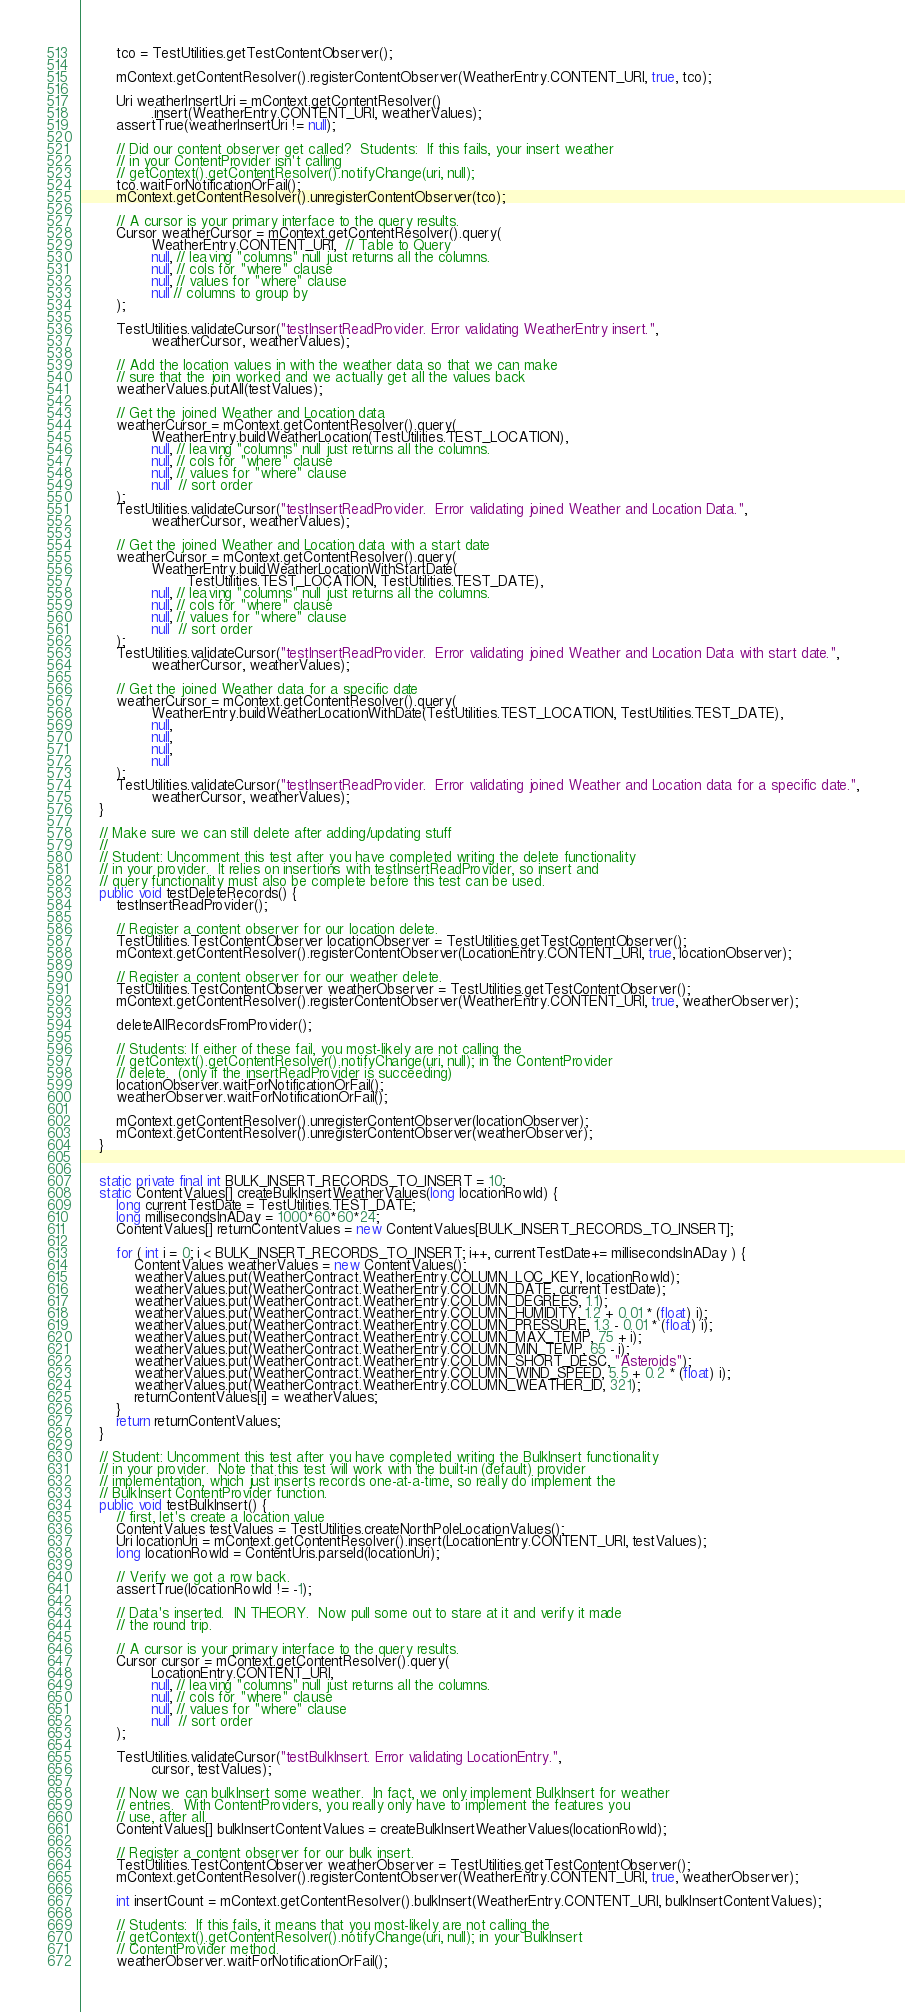Convert code to text. <code><loc_0><loc_0><loc_500><loc_500><_Java_>        tco = TestUtilities.getTestContentObserver();

        mContext.getContentResolver().registerContentObserver(WeatherEntry.CONTENT_URI, true, tco);

        Uri weatherInsertUri = mContext.getContentResolver()
                .insert(WeatherEntry.CONTENT_URI, weatherValues);
        assertTrue(weatherInsertUri != null);

        // Did our content observer get called?  Students:  If this fails, your insert weather
        // in your ContentProvider isn't calling
        // getContext().getContentResolver().notifyChange(uri, null);
        tco.waitForNotificationOrFail();
        mContext.getContentResolver().unregisterContentObserver(tco);

        // A cursor is your primary interface to the query results.
        Cursor weatherCursor = mContext.getContentResolver().query(
                WeatherEntry.CONTENT_URI,  // Table to Query
                null, // leaving "columns" null just returns all the columns.
                null, // cols for "where" clause
                null, // values for "where" clause
                null // columns to group by
        );

        TestUtilities.validateCursor("testInsertReadProvider. Error validating WeatherEntry insert.",
                weatherCursor, weatherValues);

        // Add the location values in with the weather data so that we can make
        // sure that the join worked and we actually get all the values back
        weatherValues.putAll(testValues);

        // Get the joined Weather and Location data
        weatherCursor = mContext.getContentResolver().query(
                WeatherEntry.buildWeatherLocation(TestUtilities.TEST_LOCATION),
                null, // leaving "columns" null just returns all the columns.
                null, // cols for "where" clause
                null, // values for "where" clause
                null  // sort order
        );
        TestUtilities.validateCursor("testInsertReadProvider.  Error validating joined Weather and Location Data.",
                weatherCursor, weatherValues);

        // Get the joined Weather and Location data with a start date
        weatherCursor = mContext.getContentResolver().query(
                WeatherEntry.buildWeatherLocationWithStartDate(
                        TestUtilities.TEST_LOCATION, TestUtilities.TEST_DATE),
                null, // leaving "columns" null just returns all the columns.
                null, // cols for "where" clause
                null, // values for "where" clause
                null  // sort order
        );
        TestUtilities.validateCursor("testInsertReadProvider.  Error validating joined Weather and Location Data with start date.",
                weatherCursor, weatherValues);

        // Get the joined Weather data for a specific date
        weatherCursor = mContext.getContentResolver().query(
                WeatherEntry.buildWeatherLocationWithDate(TestUtilities.TEST_LOCATION, TestUtilities.TEST_DATE),
                null,
                null,
                null,
                null
        );
        TestUtilities.validateCursor("testInsertReadProvider.  Error validating joined Weather and Location data for a specific date.",
                weatherCursor, weatherValues);
    }

    // Make sure we can still delete after adding/updating stuff
    //
    // Student: Uncomment this test after you have completed writing the delete functionality
    // in your provider.  It relies on insertions with testInsertReadProvider, so insert and
    // query functionality must also be complete before this test can be used.
    public void testDeleteRecords() {
        testInsertReadProvider();

        // Register a content observer for our location delete.
        TestUtilities.TestContentObserver locationObserver = TestUtilities.getTestContentObserver();
        mContext.getContentResolver().registerContentObserver(LocationEntry.CONTENT_URI, true, locationObserver);

        // Register a content observer for our weather delete.
        TestUtilities.TestContentObserver weatherObserver = TestUtilities.getTestContentObserver();
        mContext.getContentResolver().registerContentObserver(WeatherEntry.CONTENT_URI, true, weatherObserver);

        deleteAllRecordsFromProvider();

        // Students: If either of these fail, you most-likely are not calling the
        // getContext().getContentResolver().notifyChange(uri, null); in the ContentProvider
        // delete.  (only if the insertReadProvider is succeeding)
        locationObserver.waitForNotificationOrFail();
        weatherObserver.waitForNotificationOrFail();

        mContext.getContentResolver().unregisterContentObserver(locationObserver);
        mContext.getContentResolver().unregisterContentObserver(weatherObserver);
    }


    static private final int BULK_INSERT_RECORDS_TO_INSERT = 10;
    static ContentValues[] createBulkInsertWeatherValues(long locationRowId) {
        long currentTestDate = TestUtilities.TEST_DATE;
        long millisecondsInADay = 1000*60*60*24;
        ContentValues[] returnContentValues = new ContentValues[BULK_INSERT_RECORDS_TO_INSERT];

        for ( int i = 0; i < BULK_INSERT_RECORDS_TO_INSERT; i++, currentTestDate+= millisecondsInADay ) {
            ContentValues weatherValues = new ContentValues();
            weatherValues.put(WeatherContract.WeatherEntry.COLUMN_LOC_KEY, locationRowId);
            weatherValues.put(WeatherContract.WeatherEntry.COLUMN_DATE, currentTestDate);
            weatherValues.put(WeatherContract.WeatherEntry.COLUMN_DEGREES, 1.1);
            weatherValues.put(WeatherContract.WeatherEntry.COLUMN_HUMIDITY, 1.2 + 0.01 * (float) i);
            weatherValues.put(WeatherContract.WeatherEntry.COLUMN_PRESSURE, 1.3 - 0.01 * (float) i);
            weatherValues.put(WeatherContract.WeatherEntry.COLUMN_MAX_TEMP, 75 + i);
            weatherValues.put(WeatherContract.WeatherEntry.COLUMN_MIN_TEMP, 65 - i);
            weatherValues.put(WeatherContract.WeatherEntry.COLUMN_SHORT_DESC, "Asteroids");
            weatherValues.put(WeatherContract.WeatherEntry.COLUMN_WIND_SPEED, 5.5 + 0.2 * (float) i);
            weatherValues.put(WeatherContract.WeatherEntry.COLUMN_WEATHER_ID, 321);
            returnContentValues[i] = weatherValues;
        }
        return returnContentValues;
    }

    // Student: Uncomment this test after you have completed writing the BulkInsert functionality
    // in your provider.  Note that this test will work with the built-in (default) provider
    // implementation, which just inserts records one-at-a-time, so really do implement the
    // BulkInsert ContentProvider function.
    public void testBulkInsert() {
        // first, let's create a location value
        ContentValues testValues = TestUtilities.createNorthPoleLocationValues();
        Uri locationUri = mContext.getContentResolver().insert(LocationEntry.CONTENT_URI, testValues);
        long locationRowId = ContentUris.parseId(locationUri);

        // Verify we got a row back.
        assertTrue(locationRowId != -1);

        // Data's inserted.  IN THEORY.  Now pull some out to stare at it and verify it made
        // the round trip.

        // A cursor is your primary interface to the query results.
        Cursor cursor = mContext.getContentResolver().query(
                LocationEntry.CONTENT_URI,
                null, // leaving "columns" null just returns all the columns.
                null, // cols for "where" clause
                null, // values for "where" clause
                null  // sort order
        );

        TestUtilities.validateCursor("testBulkInsert. Error validating LocationEntry.",
                cursor, testValues);

        // Now we can bulkInsert some weather.  In fact, we only implement BulkInsert for weather
        // entries.  With ContentProviders, you really only have to implement the features you
        // use, after all.
        ContentValues[] bulkInsertContentValues = createBulkInsertWeatherValues(locationRowId);

        // Register a content observer for our bulk insert.
        TestUtilities.TestContentObserver weatherObserver = TestUtilities.getTestContentObserver();
        mContext.getContentResolver().registerContentObserver(WeatherEntry.CONTENT_URI, true, weatherObserver);

        int insertCount = mContext.getContentResolver().bulkInsert(WeatherEntry.CONTENT_URI, bulkInsertContentValues);

        // Students:  If this fails, it means that you most-likely are not calling the
        // getContext().getContentResolver().notifyChange(uri, null); in your BulkInsert
        // ContentProvider method.
        weatherObserver.waitForNotificationOrFail();</code> 